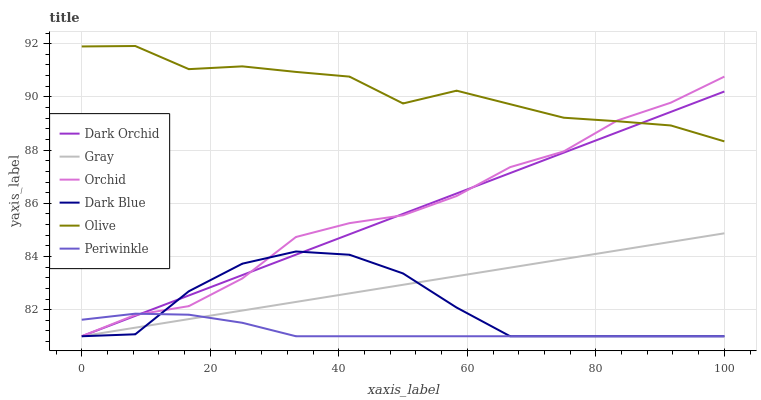Does Periwinkle have the minimum area under the curve?
Answer yes or no. Yes. Does Olive have the maximum area under the curve?
Answer yes or no. Yes. Does Dark Orchid have the minimum area under the curve?
Answer yes or no. No. Does Dark Orchid have the maximum area under the curve?
Answer yes or no. No. Is Dark Orchid the smoothest?
Answer yes or no. Yes. Is Olive the roughest?
Answer yes or no. Yes. Is Dark Blue the smoothest?
Answer yes or no. No. Is Dark Blue the roughest?
Answer yes or no. No. Does Gray have the lowest value?
Answer yes or no. Yes. Does Olive have the lowest value?
Answer yes or no. No. Does Olive have the highest value?
Answer yes or no. Yes. Does Dark Orchid have the highest value?
Answer yes or no. No. Is Periwinkle less than Olive?
Answer yes or no. Yes. Is Olive greater than Gray?
Answer yes or no. Yes. Does Orchid intersect Gray?
Answer yes or no. Yes. Is Orchid less than Gray?
Answer yes or no. No. Is Orchid greater than Gray?
Answer yes or no. No. Does Periwinkle intersect Olive?
Answer yes or no. No. 